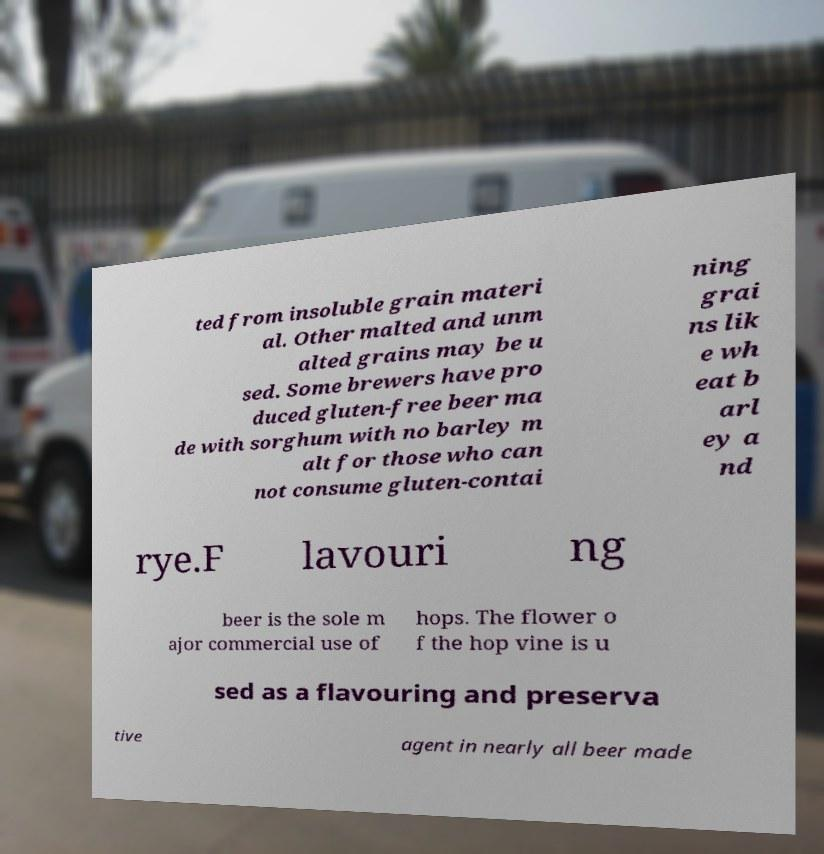For documentation purposes, I need the text within this image transcribed. Could you provide that? ted from insoluble grain materi al. Other malted and unm alted grains may be u sed. Some brewers have pro duced gluten-free beer ma de with sorghum with no barley m alt for those who can not consume gluten-contai ning grai ns lik e wh eat b arl ey a nd rye.F lavouri ng beer is the sole m ajor commercial use of hops. The flower o f the hop vine is u sed as a flavouring and preserva tive agent in nearly all beer made 